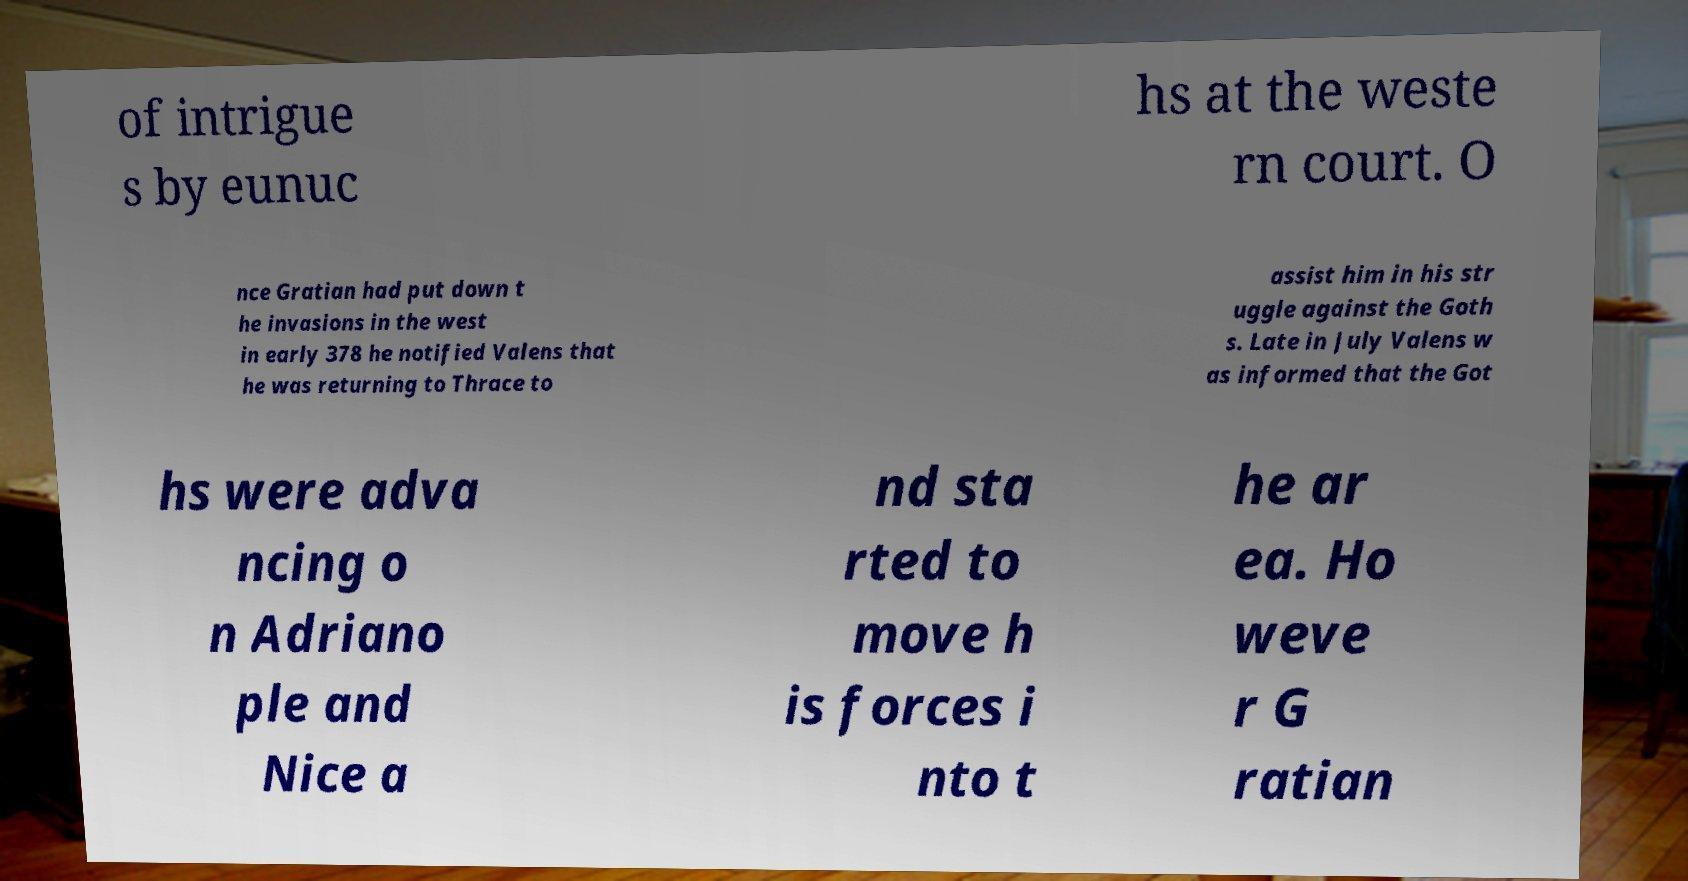Can you accurately transcribe the text from the provided image for me? of intrigue s by eunuc hs at the weste rn court. O nce Gratian had put down t he invasions in the west in early 378 he notified Valens that he was returning to Thrace to assist him in his str uggle against the Goth s. Late in July Valens w as informed that the Got hs were adva ncing o n Adriano ple and Nice a nd sta rted to move h is forces i nto t he ar ea. Ho weve r G ratian 